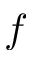Convert formula to latex. <formula><loc_0><loc_0><loc_500><loc_500>f</formula> 